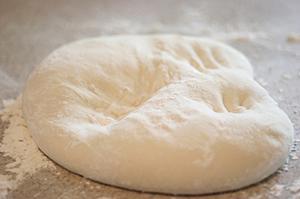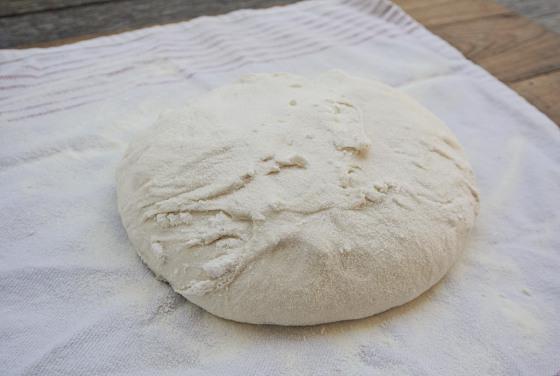The first image is the image on the left, the second image is the image on the right. Considering the images on both sides, is "Each image contains one rounded ball of dough on a floured surface, with no hands touching the ball." valid? Answer yes or no. Yes. The first image is the image on the left, the second image is the image on the right. Analyze the images presented: Is the assertion "IN at least one image there is kneaded bread next to a single bowl of flower." valid? Answer yes or no. No. 